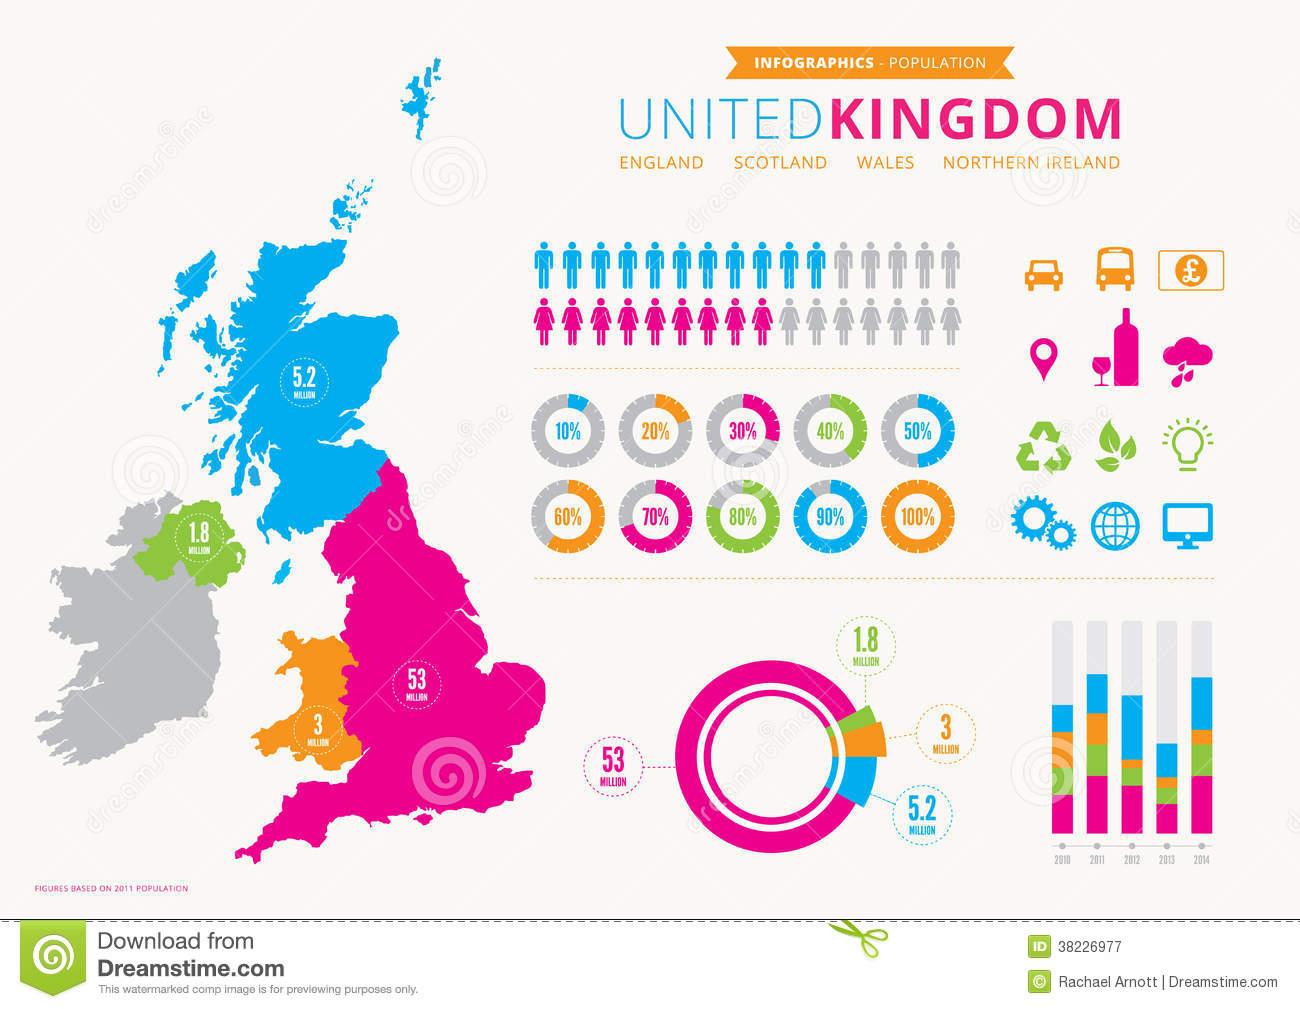Point out several critical features in this image. Scotland has a population of 5.2 million. In 2011, England had the highest population among all countries. The population of England is 53 million. The population of Wales is approximately 3 million. Scotland has the second largest population among the four countries. 